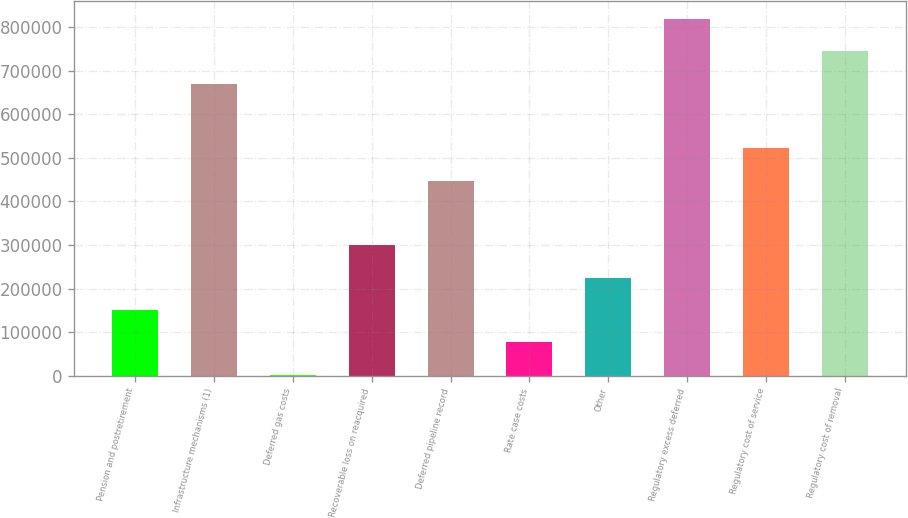Convert chart. <chart><loc_0><loc_0><loc_500><loc_500><bar_chart><fcel>Pension and postretirement<fcel>Infrastructure mechanisms (1)<fcel>Deferred gas costs<fcel>Recoverable loss on reacquired<fcel>Deferred pipeline record<fcel>Rate case costs<fcel>Other<fcel>Regulatory excess deferred<fcel>Regulatory cost of service<fcel>Regulatory cost of removal<nl><fcel>150521<fcel>670598<fcel>1927<fcel>299114<fcel>447708<fcel>76223.8<fcel>224817<fcel>819192<fcel>522005<fcel>744895<nl></chart> 